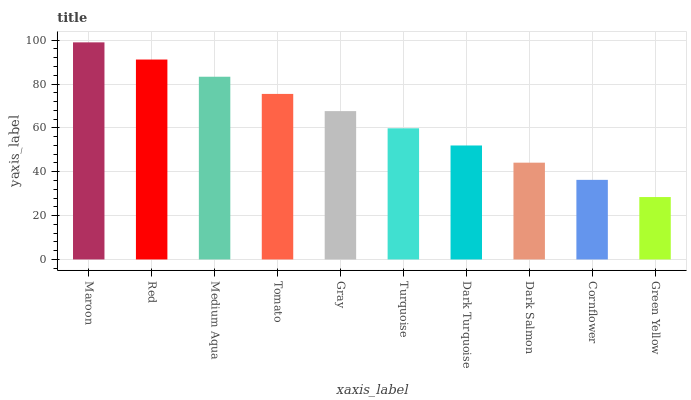Is Green Yellow the minimum?
Answer yes or no. Yes. Is Maroon the maximum?
Answer yes or no. Yes. Is Red the minimum?
Answer yes or no. No. Is Red the maximum?
Answer yes or no. No. Is Maroon greater than Red?
Answer yes or no. Yes. Is Red less than Maroon?
Answer yes or no. Yes. Is Red greater than Maroon?
Answer yes or no. No. Is Maroon less than Red?
Answer yes or no. No. Is Gray the high median?
Answer yes or no. Yes. Is Turquoise the low median?
Answer yes or no. Yes. Is Turquoise the high median?
Answer yes or no. No. Is Dark Salmon the low median?
Answer yes or no. No. 